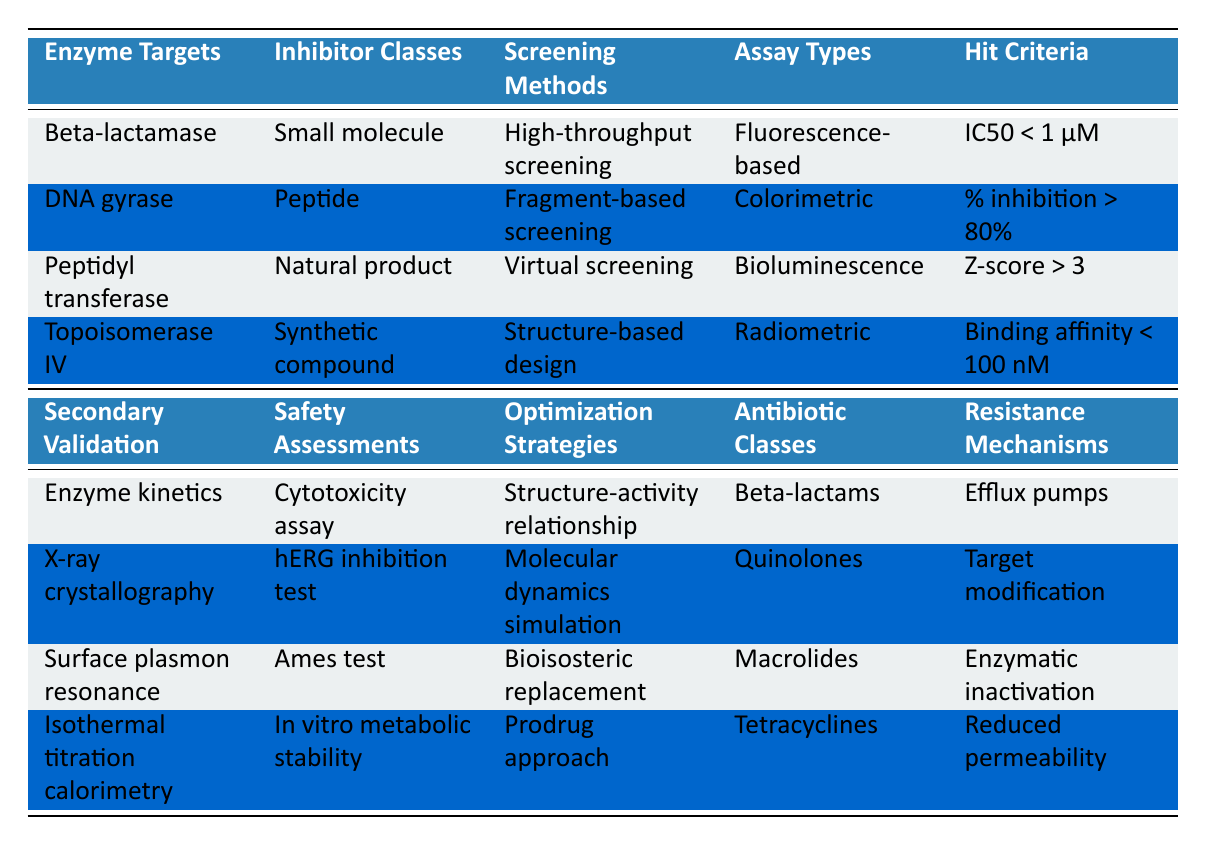What is the hit criterion for Topoisomerase IV? Referring to the corresponding row in the table, the hit criterion listed for Topoisomerase IV is "Binding affinity < 100 nM".
Answer: Binding affinity < 100 nM Which inhibitor class is associated with DNA gyrase? Looking at the table, DNA gyrase corresponds to the inhibitor class "Peptide".
Answer: Peptide How many different assay types are listed in the table? The table displays four distinct assay types: "Fluorescence-based", "Colorimetric", "Bioluminescence", and "Radiometric". Thus, there are a total of four.
Answer: 4 Is there any antibiotic class associated with a safety assessment of "hERG inhibition test"? Checking the rows, "hERG inhibition test" is paired with the antibiotic class "Quinolones". Hence the statement is true.
Answer: Yes What is the secondary validation method for the antibiotic class Macrolides? The antibiotic class Macrolides corresponds to the secondary validation method "Surface plasmon resonance" according to the table.
Answer: Surface plasmon resonance Which screening method is used with natural product inhibitors? According to the table, natural product inhibitors are screened using the method "Virtual screening".
Answer: Virtual screening What is the relationship between the safety assessments and optimization strategies? From examining the table, we can see that the first safety assessment "Cytotoxicity assay" is linked to "Structure-activity relationship" as an optimization strategy. No other combinations exhibit a direct relationship in the same row, indicating these pairings are specific.
Answer: Cytotoxicity assay and Structure-activity relationship Which resistance mechanism is listed for Beta-lactams? By reviewing the row for Beta-lactams, the resistance mechanism associated with it is "Efflux pumps".
Answer: Efflux pumps Which hit criterion includes a threshold greater than 80%? In the table, the hit criterion "% inhibition > 80%" meets the threshold of being greater than 80%.
Answer: % inhibition > 80% 